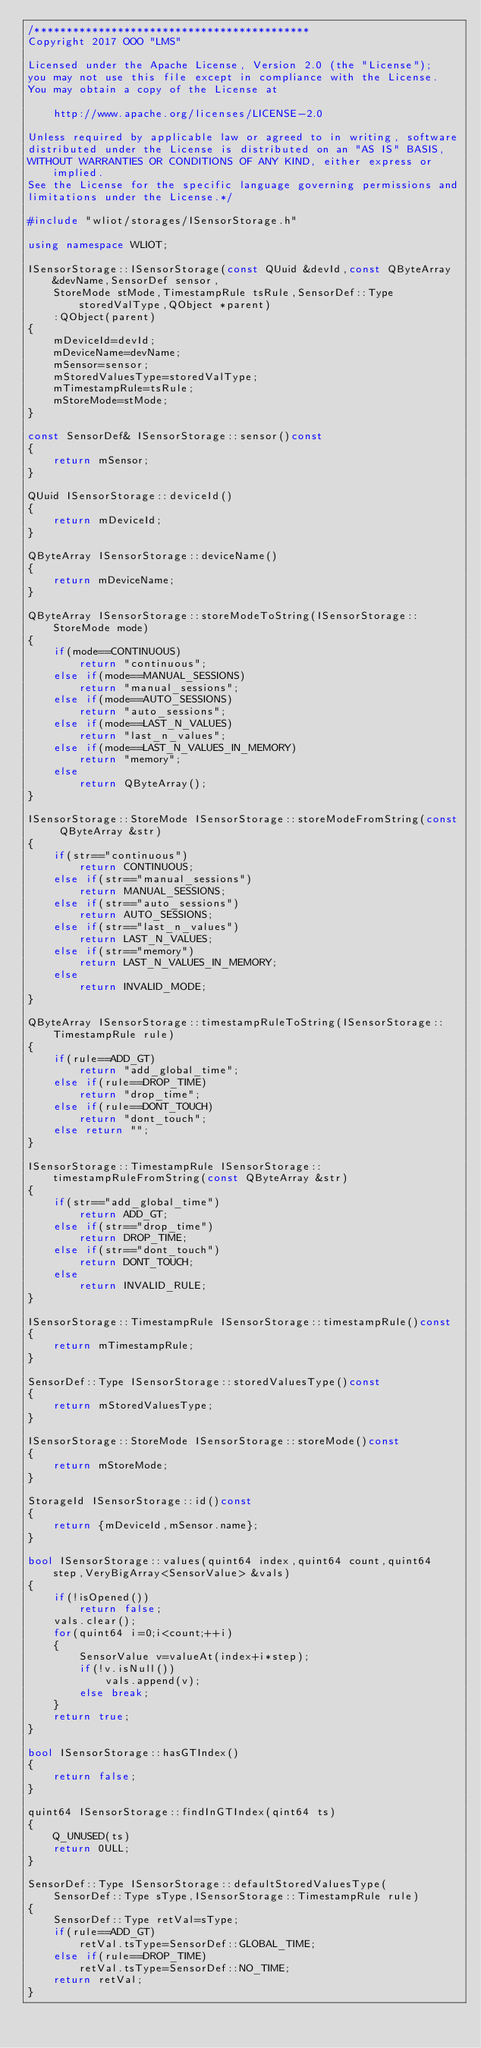Convert code to text. <code><loc_0><loc_0><loc_500><loc_500><_C++_>/*******************************************
Copyright 2017 OOO "LMS"

Licensed under the Apache License, Version 2.0 (the "License");
you may not use this file except in compliance with the License.
You may obtain a copy of the License at

	http://www.apache.org/licenses/LICENSE-2.0

Unless required by applicable law or agreed to in writing, software
distributed under the License is distributed on an "AS IS" BASIS,
WITHOUT WARRANTIES OR CONDITIONS OF ANY KIND, either express or implied.
See the License for the specific language governing permissions and
limitations under the License.*/

#include "wliot/storages/ISensorStorage.h"

using namespace WLIOT;

ISensorStorage::ISensorStorage(const QUuid &devId,const QByteArray &devName,SensorDef sensor,
	StoreMode stMode,TimestampRule tsRule,SensorDef::Type storedValType,QObject *parent)
	:QObject(parent)
{
	mDeviceId=devId;
	mDeviceName=devName;
	mSensor=sensor;
	mStoredValuesType=storedValType;
	mTimestampRule=tsRule;
	mStoreMode=stMode;
}

const SensorDef& ISensorStorage::sensor()const
{
	return mSensor;
}

QUuid ISensorStorage::deviceId()
{
	return mDeviceId;
}

QByteArray ISensorStorage::deviceName()
{
	return mDeviceName;
}

QByteArray ISensorStorage::storeModeToString(ISensorStorage::StoreMode mode)
{
	if(mode==CONTINUOUS)
		return "continuous";
	else if(mode==MANUAL_SESSIONS)
		return "manual_sessions";
	else if(mode==AUTO_SESSIONS)
		return "auto_sessions";
	else if(mode==LAST_N_VALUES)
		return "last_n_values";
	else if(mode==LAST_N_VALUES_IN_MEMORY)
		return "memory";
	else
		return QByteArray();
}

ISensorStorage::StoreMode ISensorStorage::storeModeFromString(const QByteArray &str)
{
	if(str=="continuous")
		return CONTINUOUS;
	else if(str=="manual_sessions")
		return MANUAL_SESSIONS;
	else if(str=="auto_sessions")
		return AUTO_SESSIONS;
	else if(str=="last_n_values")
		return LAST_N_VALUES;
	else if(str=="memory")
		return LAST_N_VALUES_IN_MEMORY;
	else
		return INVALID_MODE;
}

QByteArray ISensorStorage::timestampRuleToString(ISensorStorage::TimestampRule rule)
{
	if(rule==ADD_GT)
		return "add_global_time";
	else if(rule==DROP_TIME)
		return "drop_time";
	else if(rule==DONT_TOUCH)
		return "dont_touch";
	else return "";
}

ISensorStorage::TimestampRule ISensorStorage::timestampRuleFromString(const QByteArray &str)
{
	if(str=="add_global_time")
		return ADD_GT;
	else if(str=="drop_time")
		return DROP_TIME;
	else if(str=="dont_touch")
		return DONT_TOUCH;
	else
		return INVALID_RULE;
}

ISensorStorage::TimestampRule ISensorStorage::timestampRule()const
{
	return mTimestampRule;
}

SensorDef::Type ISensorStorage::storedValuesType()const
{
	return mStoredValuesType;
}

ISensorStorage::StoreMode ISensorStorage::storeMode()const
{
	return mStoreMode;
}

StorageId ISensorStorage::id()const
{
	return {mDeviceId,mSensor.name};
}

bool ISensorStorage::values(quint64 index,quint64 count,quint64 step,VeryBigArray<SensorValue> &vals)
{
	if(!isOpened())
		return false;
	vals.clear();
	for(quint64 i=0;i<count;++i)
	{
		SensorValue v=valueAt(index+i*step);
		if(!v.isNull())
			vals.append(v);
		else break;
	}
	return true;
}

bool ISensorStorage::hasGTIndex()
{
	return false;
}

quint64 ISensorStorage::findInGTIndex(qint64 ts)
{
	Q_UNUSED(ts)
	return 0ULL;
}

SensorDef::Type ISensorStorage::defaultStoredValuesType(
	SensorDef::Type sType,ISensorStorage::TimestampRule rule)
{
	SensorDef::Type retVal=sType;
	if(rule==ADD_GT)
		retVal.tsType=SensorDef::GLOBAL_TIME;
	else if(rule==DROP_TIME)
		retVal.tsType=SensorDef::NO_TIME;
	return retVal;
}
</code> 